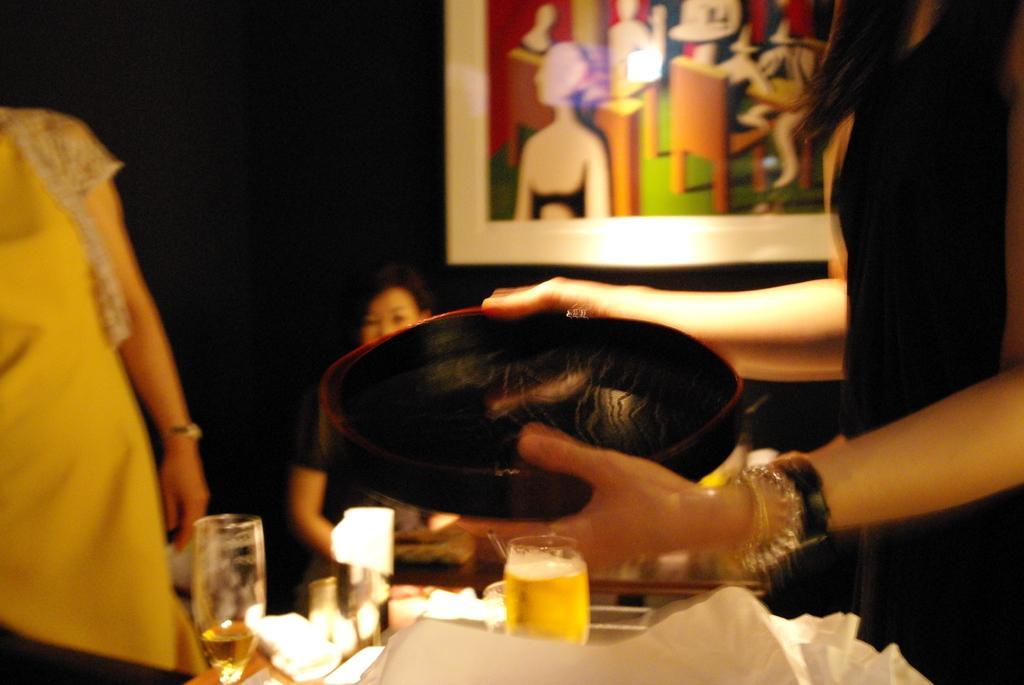Can you describe this image briefly? In this picture I can see couple of glasses and few items on the table and looks like a human hand holding a tray and I can see a woman sitting in the back and I can see another woman standing on the left side of the picture and I can see frame on the wall and I can see dark background. 